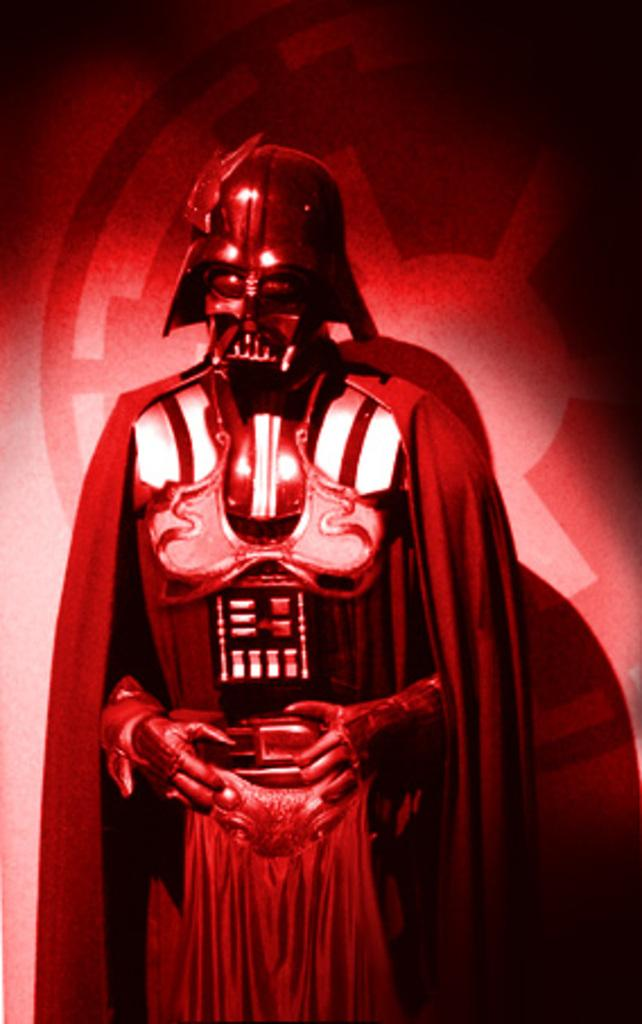What is the main subject in the image? There is a statue in the image. Can you describe the setting of the image? There is a wall in the background of the image. What type of insect can be seen crawling on the statue in the image? There is no insect present on the statue in the image. 